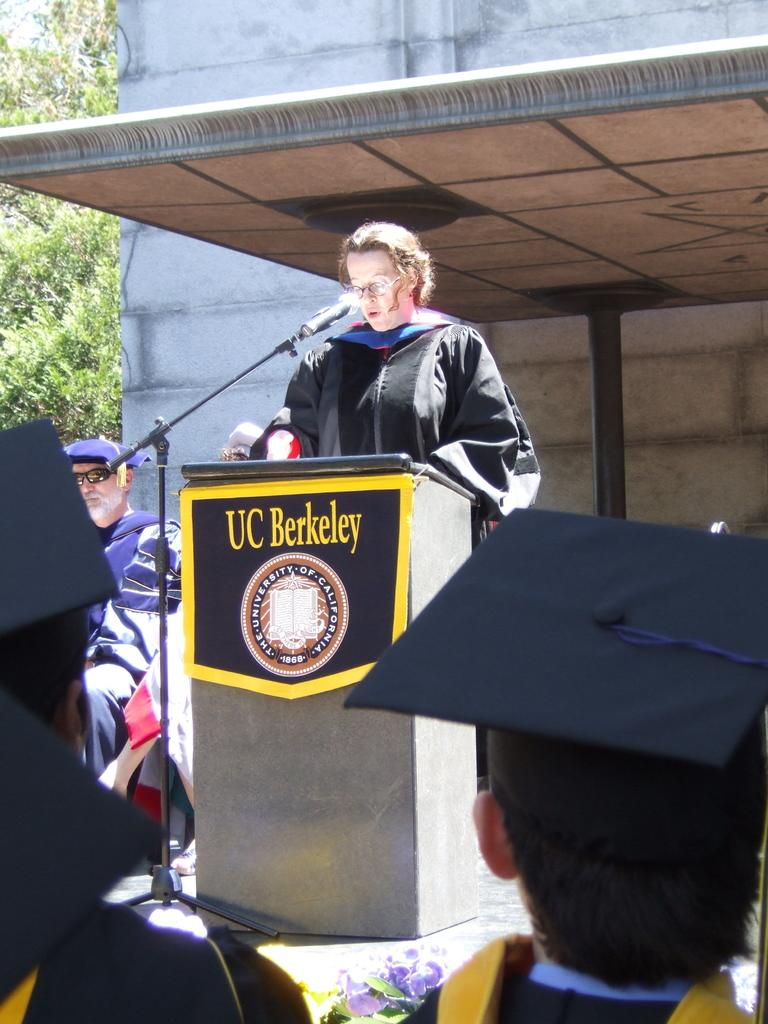What are the people in the image doing? There are persons sitting on chairs in the image, and one person is standing at a podium. What is the person at the podium doing? The person at the podium is speaking into a microphone. What can be seen in the background of the image? There are buildings and trees in the background of the image. What type of financial exchange is taking place in the image? There is no financial exchange taking place in the image; it features a person speaking at a podium with an audience. What is the interest rate for the loan mentioned in the speech? There is no mention of a loan or interest rate in the image. 